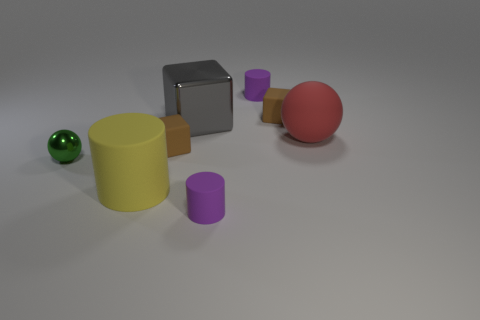What colors are the spheres in the image? There are two spheres, one is green and the other is red. 